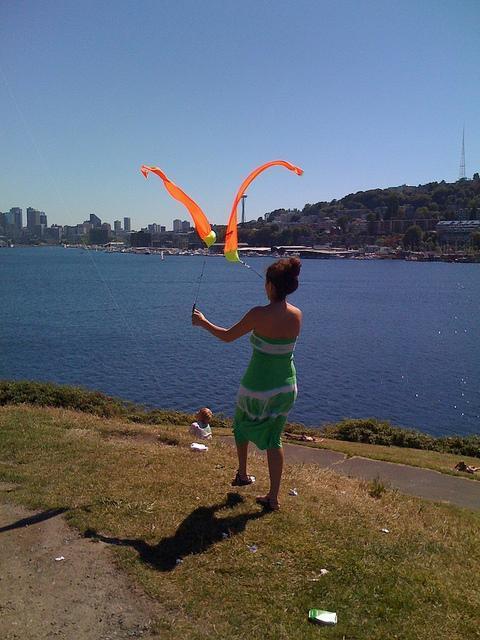How many stacks of bowls are there?
Give a very brief answer. 0. 